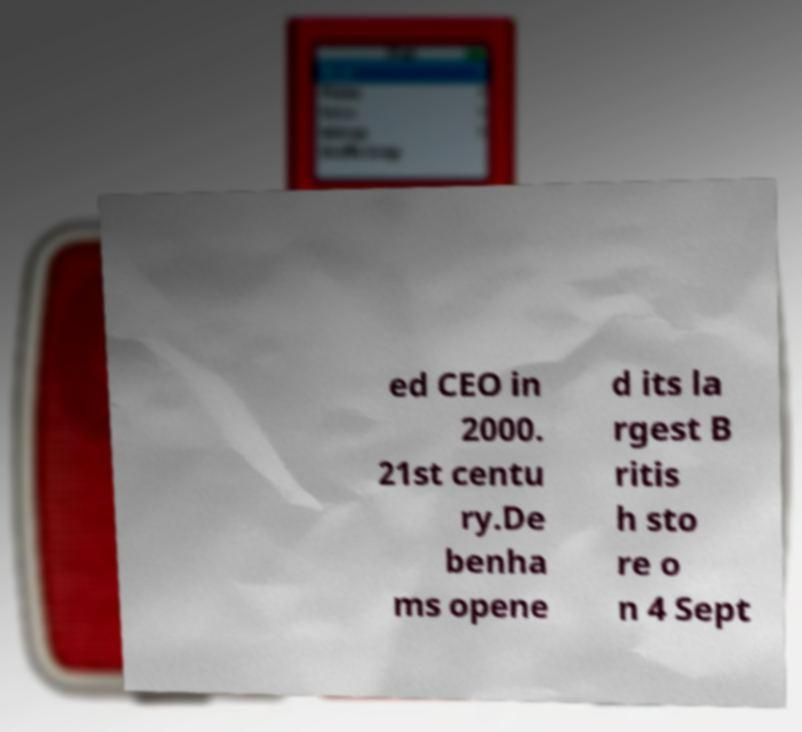Please read and relay the text visible in this image. What does it say? ed CEO in 2000. 21st centu ry.De benha ms opene d its la rgest B ritis h sto re o n 4 Sept 